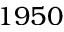Convert formula to latex. <formula><loc_0><loc_0><loc_500><loc_500>1 9 5 0</formula> 